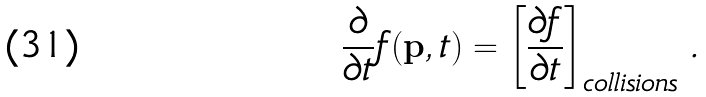Convert formula to latex. <formula><loc_0><loc_0><loc_500><loc_500>\frac { \partial } { \partial t } f ( { \mathbf p } , t ) = \left [ \frac { \partial f } { \partial t } \right ] _ { c o l l i s i o n s } \, .</formula> 